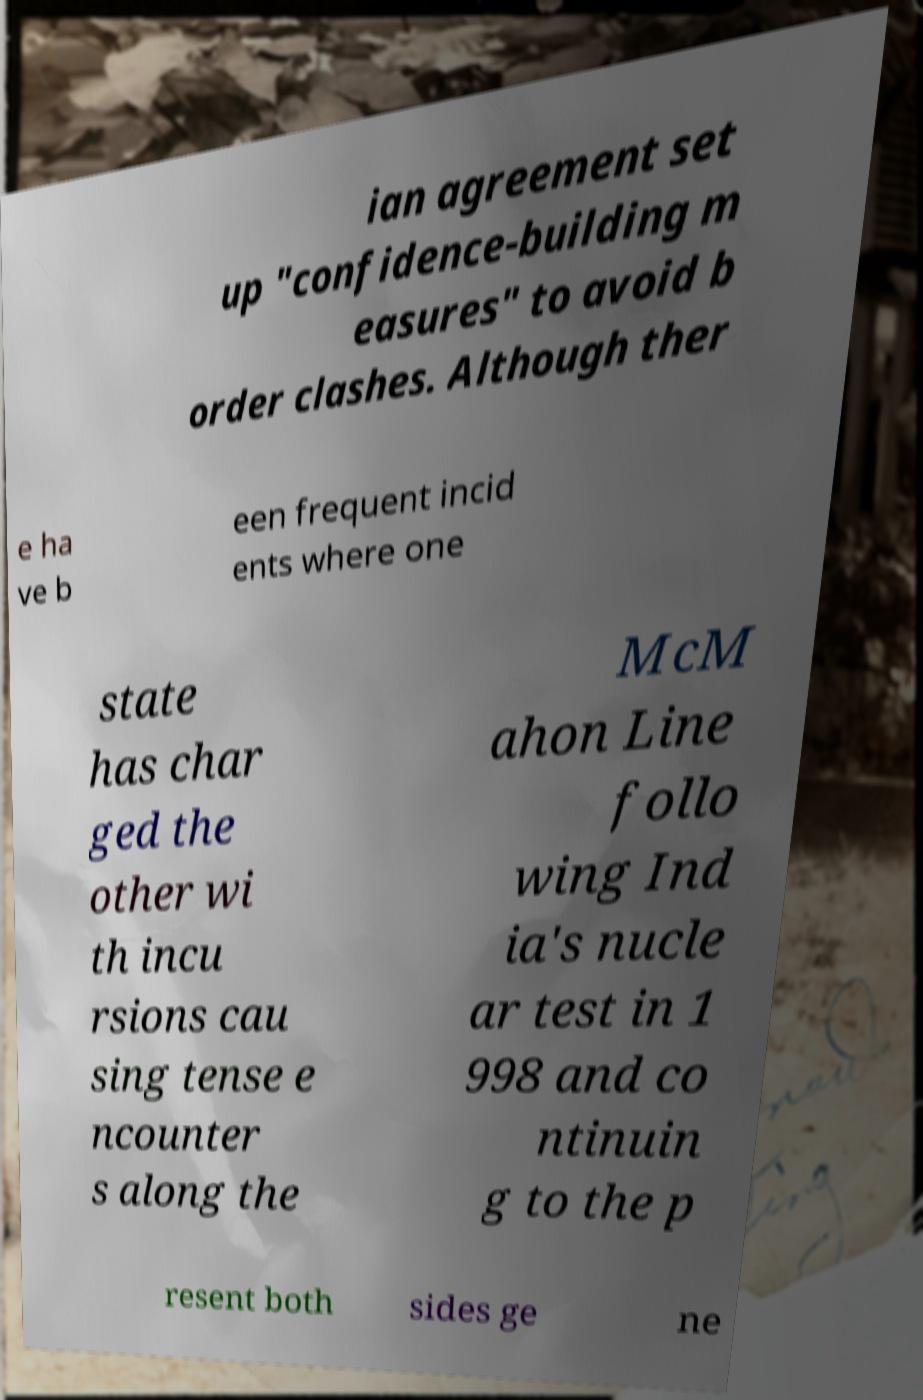What messages or text are displayed in this image? I need them in a readable, typed format. ian agreement set up "confidence-building m easures" to avoid b order clashes. Although ther e ha ve b een frequent incid ents where one state has char ged the other wi th incu rsions cau sing tense e ncounter s along the McM ahon Line follo wing Ind ia's nucle ar test in 1 998 and co ntinuin g to the p resent both sides ge ne 